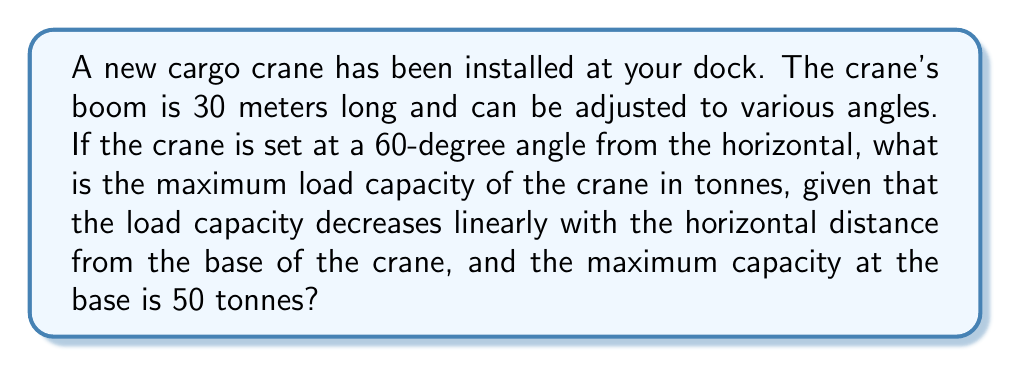Could you help me with this problem? To solve this problem, we need to follow these steps:

1) First, we need to calculate the horizontal distance from the base of the crane to the end of the boom. We can use trigonometry for this:

   Horizontal distance = $\text{boom length} \times \cos(\text{angle})$
   $$ d = 30 \times \cos(60°) = 30 \times 0.5 = 15 \text{ meters} $$

2) Now, we know that the load capacity decreases linearly with the horizontal distance. We can represent this as a linear function:

   $$ C(x) = mx + b $$

   Where $C(x)$ is the capacity at distance $x$, $m$ is the slope of the line, and $b$ is the y-intercept (the capacity at the base).

3) We know two points on this line:
   - At $x = 0$ (the base), $C(0) = 50$ tonnes
   - At $x = 30$ (the end of the fully horizontal boom), $C(30) = 0$ tonnes

4) We can use these points to find the slope $m$:

   $$ m = \frac{C(30) - C(0)}{30 - 0} = \frac{0 - 50}{30} = -\frac{5}{3} $$

5) Now we can write our linear function:

   $$ C(x) = -\frac{5}{3}x + 50 $$

6) To find the capacity at our calculated horizontal distance of 15 meters:

   $$ C(15) = -\frac{5}{3}(15) + 50 = -25 + 50 = 25 $$

Therefore, the maximum load capacity of the crane at a 60-degree angle is 25 tonnes.
Answer: 25 tonnes 